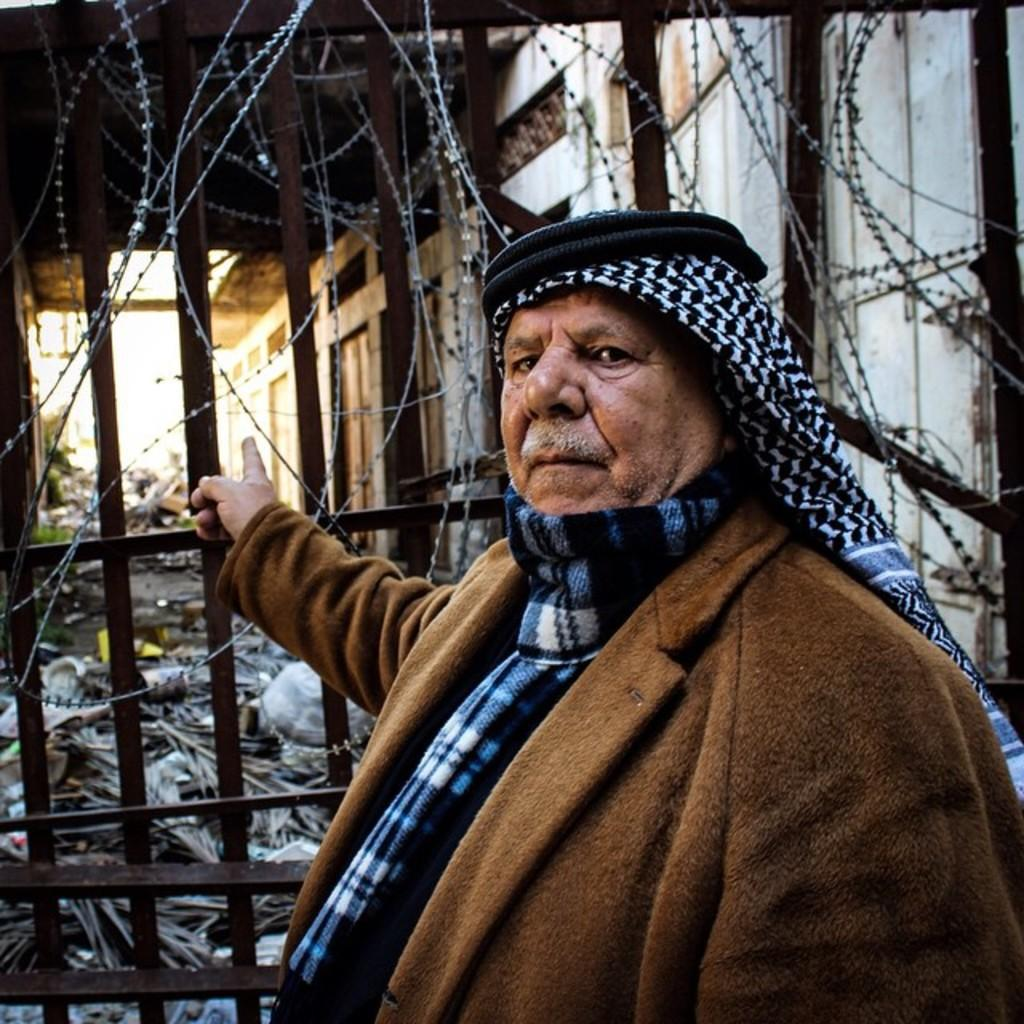What is the main subject in the image? There is a person in the image. What type of structure can be seen in the image? There is a gate in the image. What type of barrier is present in the image? There is fencing in the image. What type of snow can be seen in the image? There is no snow present in the image. What type of market can be seen in the image? There is no market present in the image. 